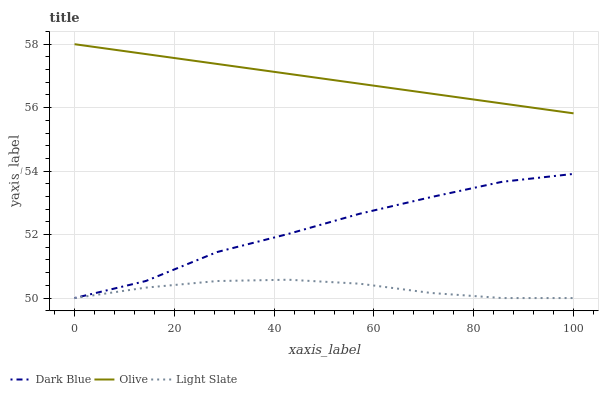Does Light Slate have the minimum area under the curve?
Answer yes or no. Yes. Does Olive have the maximum area under the curve?
Answer yes or no. Yes. Does Dark Blue have the minimum area under the curve?
Answer yes or no. No. Does Dark Blue have the maximum area under the curve?
Answer yes or no. No. Is Olive the smoothest?
Answer yes or no. Yes. Is Dark Blue the roughest?
Answer yes or no. Yes. Is Light Slate the smoothest?
Answer yes or no. No. Is Light Slate the roughest?
Answer yes or no. No. Does Dark Blue have the lowest value?
Answer yes or no. Yes. Does Olive have the highest value?
Answer yes or no. Yes. Does Dark Blue have the highest value?
Answer yes or no. No. Is Light Slate less than Olive?
Answer yes or no. Yes. Is Olive greater than Light Slate?
Answer yes or no. Yes. Does Dark Blue intersect Light Slate?
Answer yes or no. Yes. Is Dark Blue less than Light Slate?
Answer yes or no. No. Is Dark Blue greater than Light Slate?
Answer yes or no. No. Does Light Slate intersect Olive?
Answer yes or no. No. 